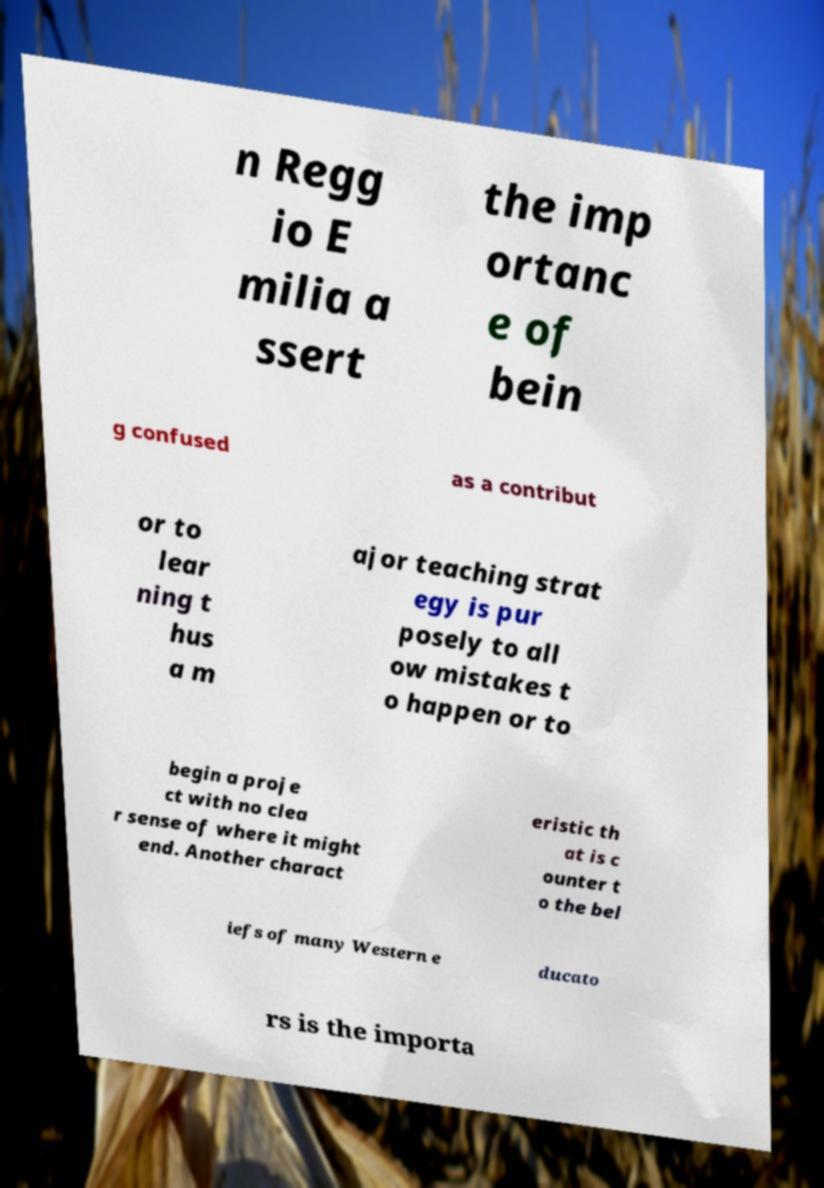I need the written content from this picture converted into text. Can you do that? n Regg io E milia a ssert the imp ortanc e of bein g confused as a contribut or to lear ning t hus a m ajor teaching strat egy is pur posely to all ow mistakes t o happen or to begin a proje ct with no clea r sense of where it might end. Another charact eristic th at is c ounter t o the bel iefs of many Western e ducato rs is the importa 